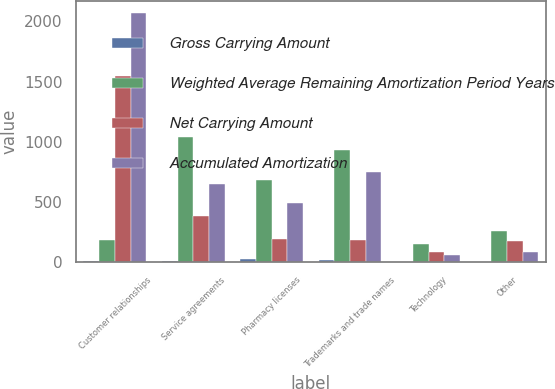Convert chart. <chart><loc_0><loc_0><loc_500><loc_500><stacked_bar_chart><ecel><fcel>Customer relationships<fcel>Service agreements<fcel>Pharmacy licenses<fcel>Trademarks and trade names<fcel>Technology<fcel>Other<nl><fcel>Gross Carrying Amount<fcel>12<fcel>12<fcel>26<fcel>14<fcel>4<fcel>4<nl><fcel>Weighted Average Remaining Amortization Period Years<fcel>187<fcel>1037<fcel>684<fcel>932<fcel>147<fcel>262<nl><fcel>Net Carrying Amount<fcel>1550<fcel>386<fcel>196<fcel>187<fcel>84<fcel>176<nl><fcel>Accumulated Amortization<fcel>2069<fcel>651<fcel>488<fcel>745<fcel>63<fcel>86<nl></chart> 